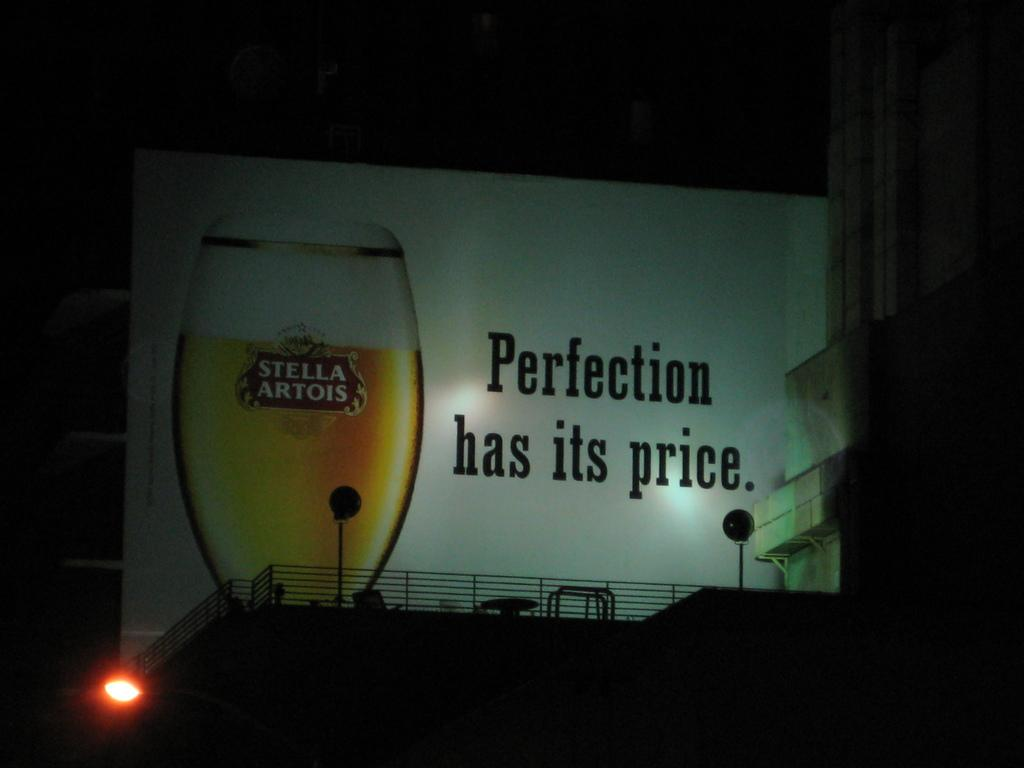<image>
Provide a brief description of the given image. A banner advertising Stella Artois with the slogan Perfectio has Its Price. 